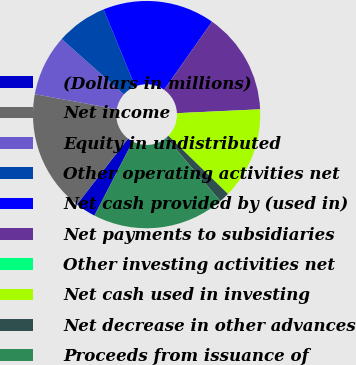<chart> <loc_0><loc_0><loc_500><loc_500><pie_chart><fcel>(Dollars in millions)<fcel>Net income<fcel>Equity in undistributed<fcel>Other operating activities net<fcel>Net cash provided by (used in)<fcel>Net payments to subsidiaries<fcel>Other investing activities net<fcel>Net cash used in investing<fcel>Net decrease in other advances<fcel>Proceeds from issuance of<nl><fcel>2.91%<fcel>17.38%<fcel>8.7%<fcel>7.25%<fcel>15.94%<fcel>14.49%<fcel>0.01%<fcel>13.04%<fcel>1.46%<fcel>18.83%<nl></chart> 